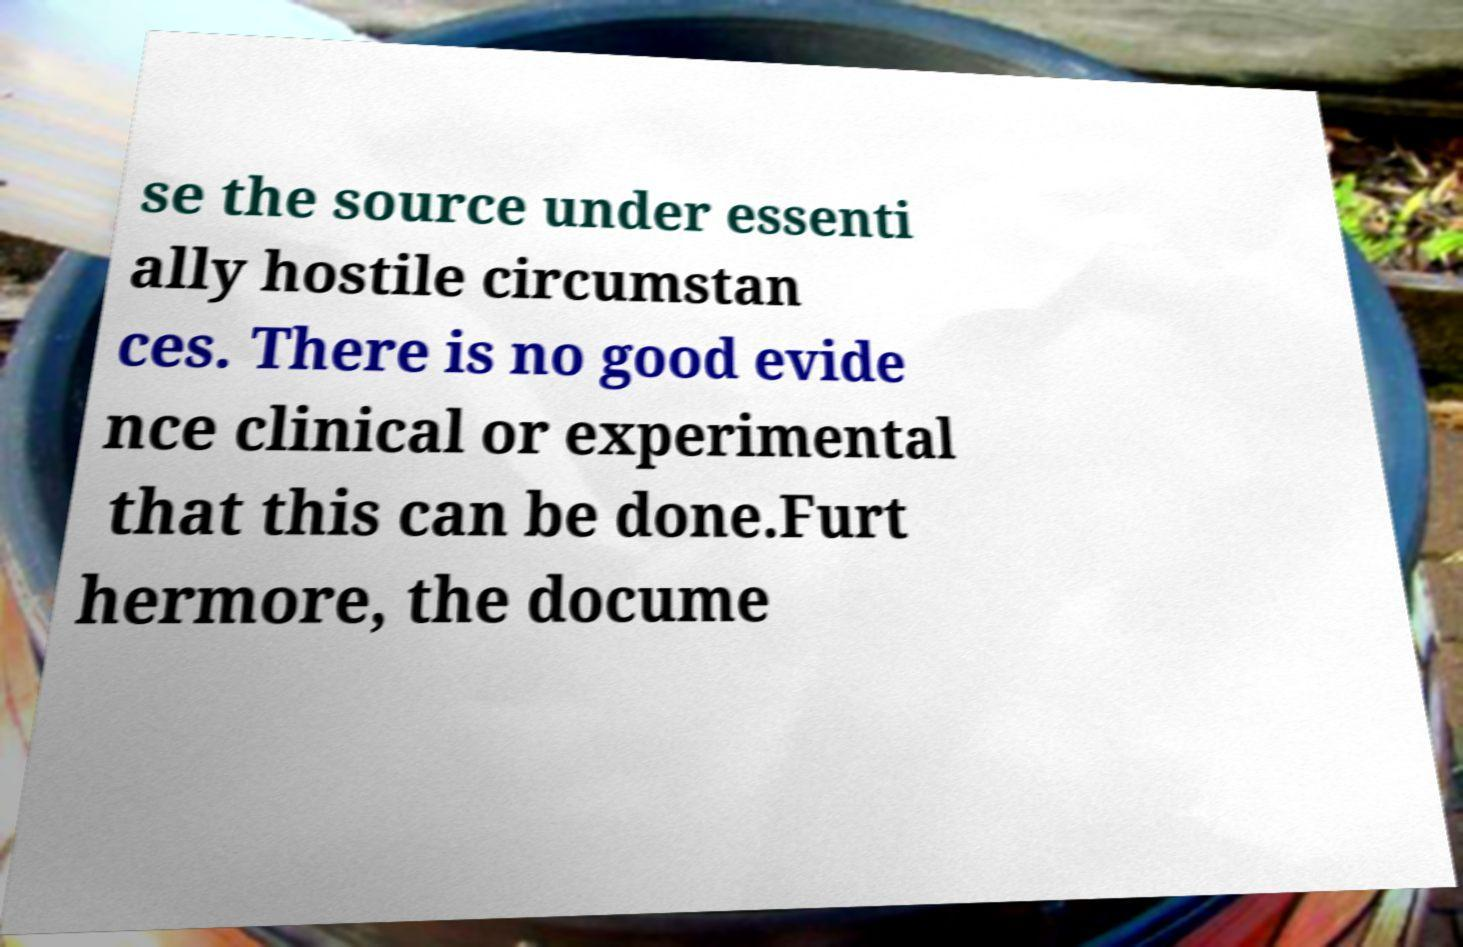Can you read and provide the text displayed in the image?This photo seems to have some interesting text. Can you extract and type it out for me? se the source under essenti ally hostile circumstan ces. There is no good evide nce clinical or experimental that this can be done.Furt hermore, the docume 